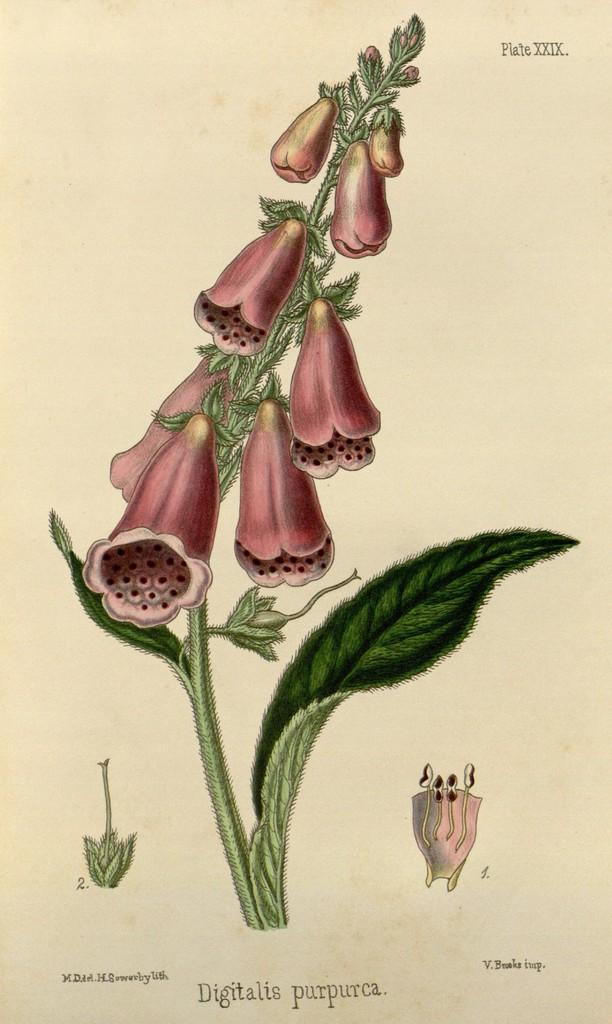What is depicted in the sketch in the image? There is a sketch of a plant in the image. What additional elements can be seen in the image? There are flowers in the image. What is written or drawn on the paper in the image? There is text on the paper in the image. Can you describe the pear that is being held by the deer in the image? There is no pear or deer present in the image; it features a sketch of a plant, flowers, and text on the paper. 